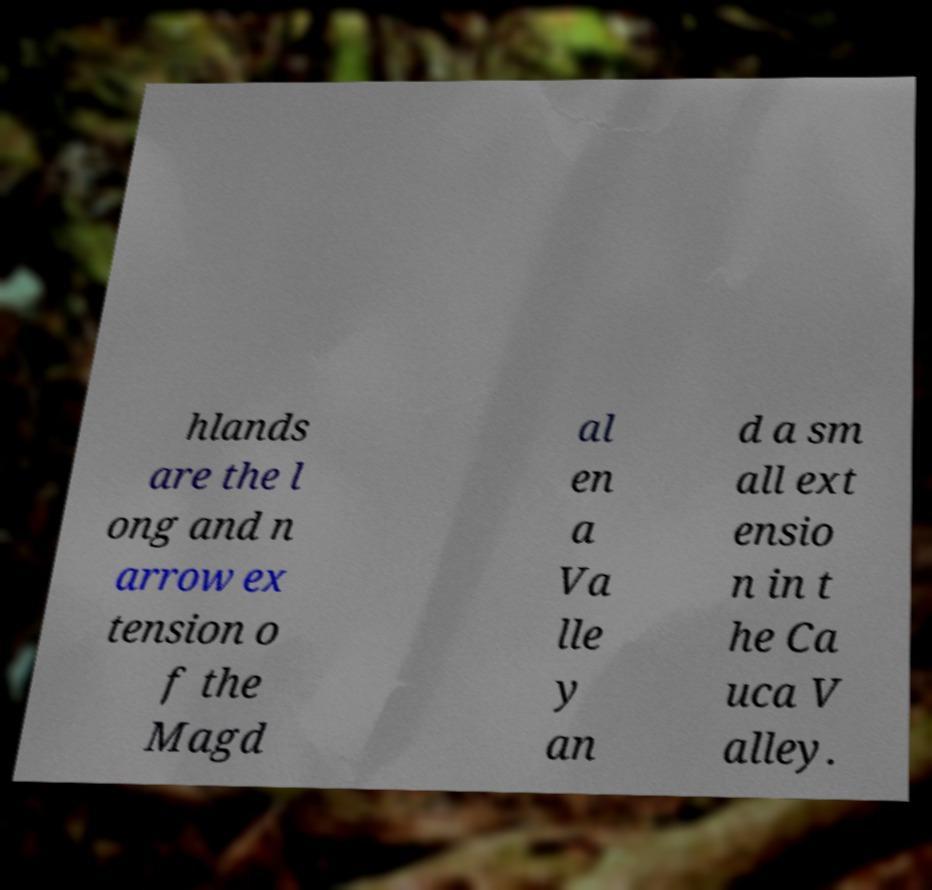There's text embedded in this image that I need extracted. Can you transcribe it verbatim? hlands are the l ong and n arrow ex tension o f the Magd al en a Va lle y an d a sm all ext ensio n in t he Ca uca V alley. 